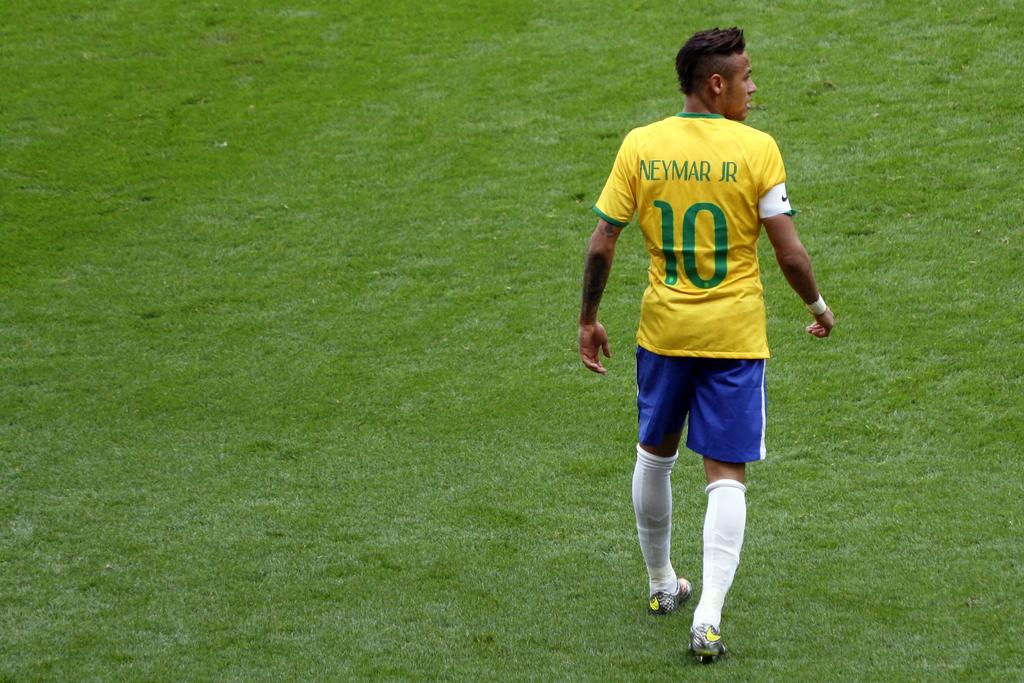What is the number on his jersey?
Provide a succinct answer. 10. 